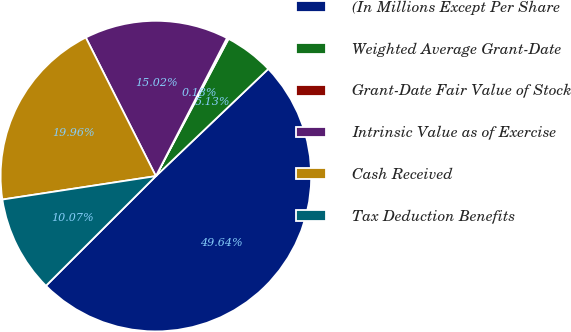<chart> <loc_0><loc_0><loc_500><loc_500><pie_chart><fcel>(In Millions Except Per Share<fcel>Weighted Average Grant-Date<fcel>Grant-Date Fair Value of Stock<fcel>Intrinsic Value as of Exercise<fcel>Cash Received<fcel>Tax Deduction Benefits<nl><fcel>49.64%<fcel>5.13%<fcel>0.18%<fcel>15.02%<fcel>19.96%<fcel>10.07%<nl></chart> 